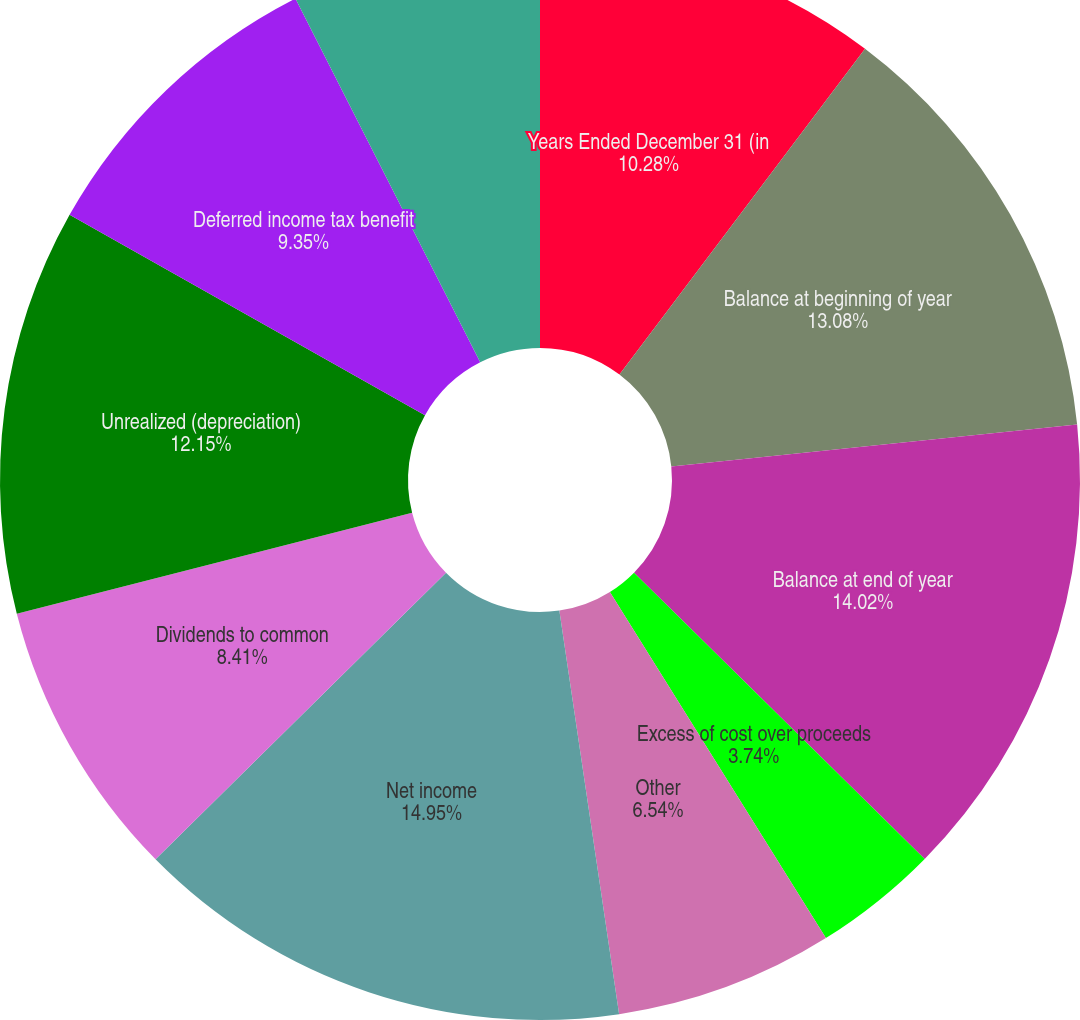<chart> <loc_0><loc_0><loc_500><loc_500><pie_chart><fcel>Years Ended December 31 (in<fcel>Balance at beginning of year<fcel>Balance at end of year<fcel>Excess of cost over proceeds<fcel>Other<fcel>Net income<fcel>Dividends to common<fcel>Unrealized (depreciation)<fcel>Deferred income tax benefit<fcel>Foreign currency translation<nl><fcel>10.28%<fcel>13.08%<fcel>14.02%<fcel>3.74%<fcel>6.54%<fcel>14.95%<fcel>8.41%<fcel>12.15%<fcel>9.35%<fcel>7.48%<nl></chart> 